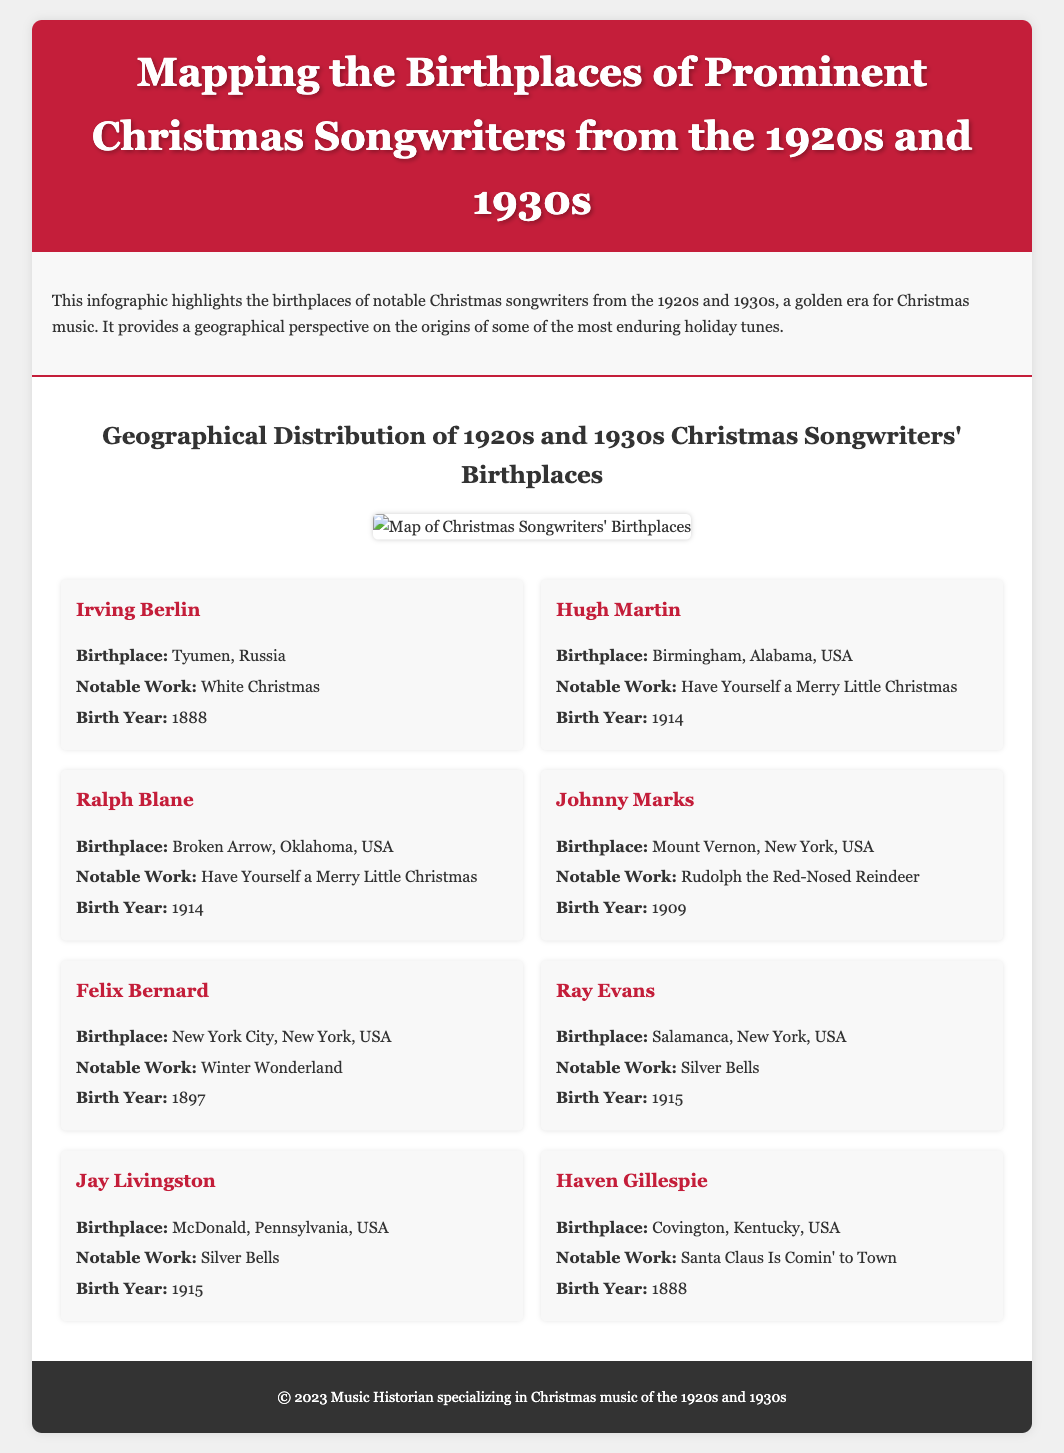What is the title of the infographic? The title is provided in the header section of the document.
Answer: Mapping the Birthplaces of Prominent Christmas Songwriters from the 1920s and 1930s Who is the songwriter born in Tyumen, Russia? The document lists the birthplaces and notable works of various songwriters, including the one from Tyumen, Russia.
Answer: Irving Berlin Which notable Christmas song was written by Johnny Marks? The document specifies the notable works of each songwriter, including Johnny Marks.
Answer: Rudolph the Red-Nosed Reindeer How many songwriters are highlighted in the infographic? The songwriters are listed in separate sections, allowing for easy counting.
Answer: Eight What is the birthplace of Hugh Martin? The birthplace is mentioned with each songwriter's information in the document.
Answer: Birmingham, Alabama, USA Which songwriter shares a birthplace with Ray Evans? This requires reasoning to find the additional songwriter born in Salamanca, New York, USA, as they are both mentioned.
Answer: None What is the birth year of Felix Bernard? The document includes the birth year for each songwriter listed.
Answer: 1897 Which song is associated with Haven Gillespie? The notable work is provided along with each songwriter’s details.
Answer: Santa Claus Is Comin' to Town What type of music does the infographic focus on? The description at the beginning provides insight into the content focus of the document.
Answer: Christmas music 